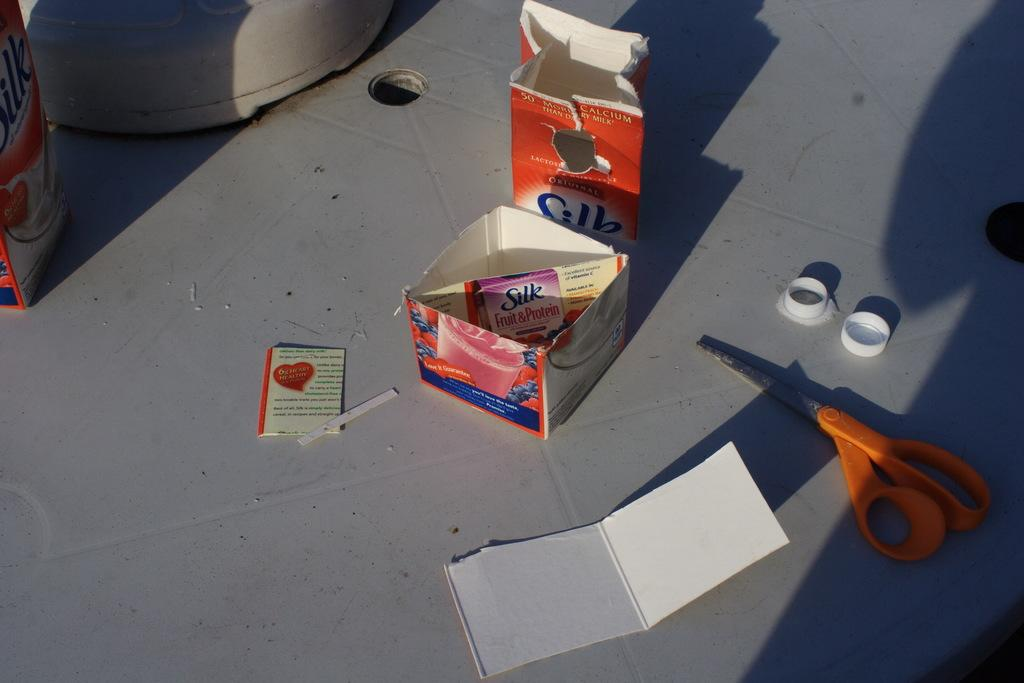<image>
Give a short and clear explanation of the subsequent image. A cut apart carton of Silk milk and a pair of scissors. 